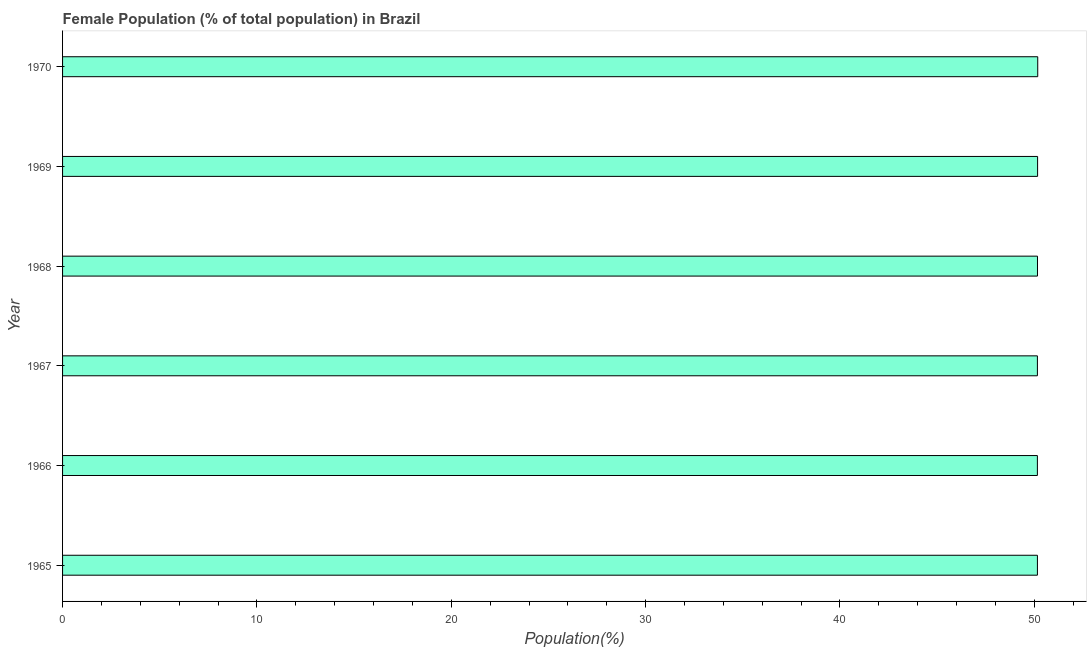What is the title of the graph?
Your answer should be very brief. Female Population (% of total population) in Brazil. What is the label or title of the X-axis?
Give a very brief answer. Population(%). What is the label or title of the Y-axis?
Give a very brief answer. Year. What is the female population in 1965?
Give a very brief answer. 50.16. Across all years, what is the maximum female population?
Offer a very short reply. 50.18. Across all years, what is the minimum female population?
Your answer should be compact. 50.16. In which year was the female population minimum?
Provide a short and direct response. 1966. What is the sum of the female population?
Provide a short and direct response. 300.98. What is the difference between the female population in 1967 and 1970?
Provide a short and direct response. -0.02. What is the average female population per year?
Offer a very short reply. 50.16. What is the median female population?
Ensure brevity in your answer.  50.16. What is the ratio of the female population in 1966 to that in 1969?
Provide a short and direct response. 1. Is the female population in 1965 less than that in 1966?
Your response must be concise. No. Is the difference between the female population in 1965 and 1969 greater than the difference between any two years?
Offer a terse response. No. What is the difference between the highest and the second highest female population?
Give a very brief answer. 0.01. Is the sum of the female population in 1968 and 1970 greater than the maximum female population across all years?
Provide a short and direct response. Yes. How many bars are there?
Your answer should be compact. 6. How many years are there in the graph?
Offer a terse response. 6. What is the difference between two consecutive major ticks on the X-axis?
Your response must be concise. 10. What is the Population(%) in 1965?
Keep it short and to the point. 50.16. What is the Population(%) of 1966?
Offer a terse response. 50.16. What is the Population(%) of 1967?
Make the answer very short. 50.16. What is the Population(%) of 1968?
Offer a terse response. 50.16. What is the Population(%) of 1969?
Keep it short and to the point. 50.17. What is the Population(%) in 1970?
Your answer should be compact. 50.18. What is the difference between the Population(%) in 1965 and 1966?
Provide a succinct answer. 0. What is the difference between the Population(%) in 1965 and 1967?
Your answer should be compact. 0. What is the difference between the Population(%) in 1965 and 1968?
Provide a short and direct response. -0. What is the difference between the Population(%) in 1965 and 1969?
Offer a terse response. -0.01. What is the difference between the Population(%) in 1965 and 1970?
Provide a succinct answer. -0.02. What is the difference between the Population(%) in 1966 and 1967?
Provide a short and direct response. -0. What is the difference between the Population(%) in 1966 and 1968?
Ensure brevity in your answer.  -0. What is the difference between the Population(%) in 1966 and 1969?
Ensure brevity in your answer.  -0.01. What is the difference between the Population(%) in 1966 and 1970?
Your answer should be very brief. -0.02. What is the difference between the Population(%) in 1967 and 1968?
Your answer should be compact. -0. What is the difference between the Population(%) in 1967 and 1969?
Provide a short and direct response. -0.01. What is the difference between the Population(%) in 1967 and 1970?
Your answer should be compact. -0.02. What is the difference between the Population(%) in 1968 and 1969?
Keep it short and to the point. -0.01. What is the difference between the Population(%) in 1968 and 1970?
Give a very brief answer. -0.01. What is the difference between the Population(%) in 1969 and 1970?
Offer a terse response. -0.01. What is the ratio of the Population(%) in 1965 to that in 1967?
Provide a succinct answer. 1. What is the ratio of the Population(%) in 1965 to that in 1968?
Ensure brevity in your answer.  1. What is the ratio of the Population(%) in 1965 to that in 1970?
Your answer should be compact. 1. What is the ratio of the Population(%) in 1966 to that in 1968?
Provide a succinct answer. 1. What is the ratio of the Population(%) in 1966 to that in 1969?
Provide a short and direct response. 1. What is the ratio of the Population(%) in 1967 to that in 1968?
Provide a short and direct response. 1. What is the ratio of the Population(%) in 1967 to that in 1969?
Make the answer very short. 1. What is the ratio of the Population(%) in 1968 to that in 1970?
Offer a terse response. 1. 